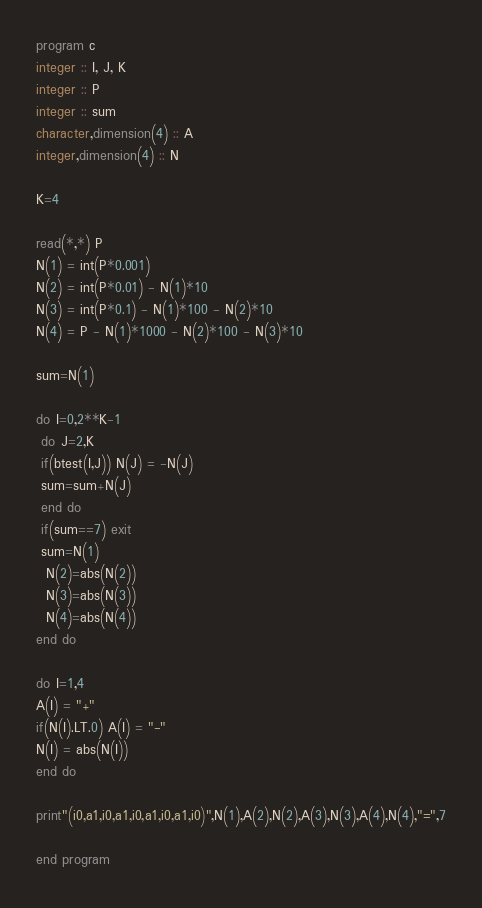Convert code to text. <code><loc_0><loc_0><loc_500><loc_500><_FORTRAN_>program c
integer :: I, J, K
integer :: P
integer :: sum
character,dimension(4) :: A 
integer,dimension(4) :: N

K=4

read(*,*) P
N(1) = int(P*0.001)
N(2) = int(P*0.01) - N(1)*10
N(3) = int(P*0.1) - N(1)*100 - N(2)*10
N(4) = P - N(1)*1000 - N(2)*100 - N(3)*10

sum=N(1)

do I=0,2**K-1
 do J=2,K
 if(btest(I,J)) N(J) = -N(J)
 sum=sum+N(J)
 end do
 if(sum==7) exit
 sum=N(1)
  N(2)=abs(N(2)) 
  N(3)=abs(N(3))
  N(4)=abs(N(4))
end do

do I=1,4
A(I) = "+"
if(N(I).LT.0) A(I) = "-"
N(I) = abs(N(I))
end do

print"(i0,a1,i0,a1,i0,a1,i0,a1,i0)",N(1),A(2),N(2),A(3),N(3),A(4),N(4),"=",7

end program</code> 